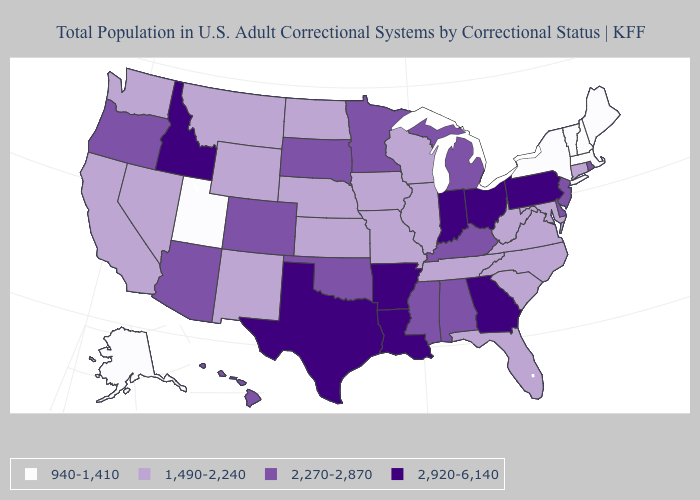Name the states that have a value in the range 1,490-2,240?
Give a very brief answer. California, Connecticut, Florida, Illinois, Iowa, Kansas, Maryland, Missouri, Montana, Nebraska, Nevada, New Mexico, North Carolina, North Dakota, South Carolina, Tennessee, Virginia, Washington, West Virginia, Wisconsin, Wyoming. What is the lowest value in the MidWest?
Write a very short answer. 1,490-2,240. Does Colorado have a higher value than Wisconsin?
Be succinct. Yes. What is the value of Arkansas?
Quick response, please. 2,920-6,140. What is the value of Nevada?
Concise answer only. 1,490-2,240. Name the states that have a value in the range 2,920-6,140?
Be succinct. Arkansas, Georgia, Idaho, Indiana, Louisiana, Ohio, Pennsylvania, Texas. Is the legend a continuous bar?
Give a very brief answer. No. What is the value of Vermont?
Write a very short answer. 940-1,410. Name the states that have a value in the range 2,270-2,870?
Quick response, please. Alabama, Arizona, Colorado, Delaware, Hawaii, Kentucky, Michigan, Minnesota, Mississippi, New Jersey, Oklahoma, Oregon, Rhode Island, South Dakota. What is the value of Rhode Island?
Answer briefly. 2,270-2,870. Does Massachusetts have the lowest value in the USA?
Short answer required. Yes. What is the highest value in the USA?
Be succinct. 2,920-6,140. What is the value of Louisiana?
Give a very brief answer. 2,920-6,140. Which states have the highest value in the USA?
Answer briefly. Arkansas, Georgia, Idaho, Indiana, Louisiana, Ohio, Pennsylvania, Texas. What is the value of Ohio?
Short answer required. 2,920-6,140. 